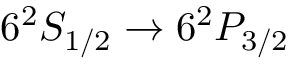Convert formula to latex. <formula><loc_0><loc_0><loc_500><loc_500>6 ^ { 2 } S _ { 1 / 2 } \rightarrow 6 ^ { 2 } P _ { 3 / 2 }</formula> 